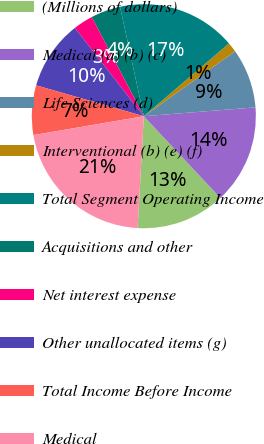Convert chart to OTSL. <chart><loc_0><loc_0><loc_500><loc_500><pie_chart><fcel>(Millions of dollars)<fcel>Medical (a) (b) (c)<fcel>Life Sciences (d)<fcel>Interventional (b) (e) (f)<fcel>Total Segment Operating Income<fcel>Acquisitions and other<fcel>Net interest expense<fcel>Other unallocated items (g)<fcel>Total Income Before Income<fcel>Medical<nl><fcel>12.86%<fcel>14.28%<fcel>8.57%<fcel>1.43%<fcel>17.14%<fcel>4.29%<fcel>2.86%<fcel>10.0%<fcel>7.14%<fcel>21.42%<nl></chart> 